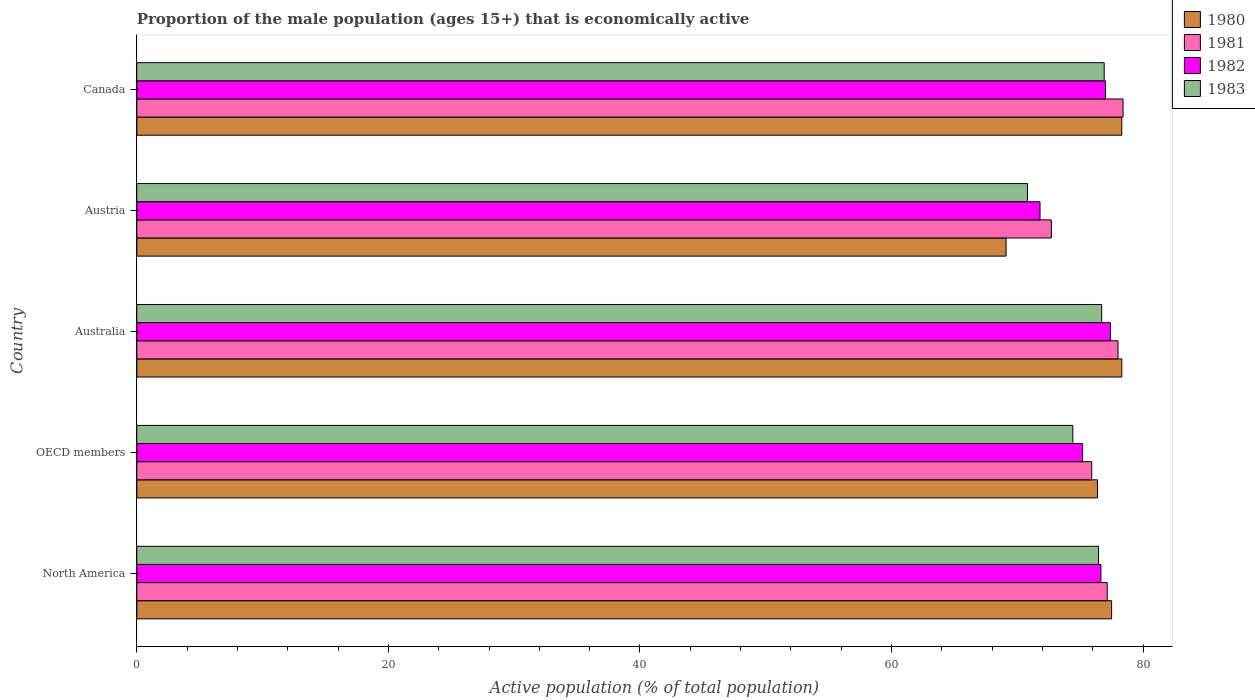Are the number of bars per tick equal to the number of legend labels?
Your response must be concise. Yes. How many bars are there on the 1st tick from the top?
Make the answer very short. 4. How many bars are there on the 4th tick from the bottom?
Ensure brevity in your answer.  4. In how many cases, is the number of bars for a given country not equal to the number of legend labels?
Give a very brief answer. 0. What is the proportion of the male population that is economically active in 1983 in North America?
Keep it short and to the point. 76.45. Across all countries, what is the maximum proportion of the male population that is economically active in 1983?
Provide a succinct answer. 76.9. Across all countries, what is the minimum proportion of the male population that is economically active in 1981?
Your answer should be compact. 72.7. In which country was the proportion of the male population that is economically active in 1980 maximum?
Provide a short and direct response. Australia. What is the total proportion of the male population that is economically active in 1982 in the graph?
Keep it short and to the point. 378.02. What is the difference between the proportion of the male population that is economically active in 1980 in Australia and that in OECD members?
Your response must be concise. 1.93. What is the difference between the proportion of the male population that is economically active in 1980 in Austria and the proportion of the male population that is economically active in 1983 in Canada?
Provide a succinct answer. -7.8. What is the average proportion of the male population that is economically active in 1982 per country?
Offer a terse response. 75.6. What is the difference between the proportion of the male population that is economically active in 1983 and proportion of the male population that is economically active in 1981 in Australia?
Make the answer very short. -1.3. In how many countries, is the proportion of the male population that is economically active in 1982 greater than 52 %?
Make the answer very short. 5. What is the ratio of the proportion of the male population that is economically active in 1982 in Austria to that in Canada?
Your answer should be compact. 0.93. What is the difference between the highest and the second highest proportion of the male population that is economically active in 1982?
Offer a terse response. 0.4. What is the difference between the highest and the lowest proportion of the male population that is economically active in 1980?
Your answer should be very brief. 9.2. In how many countries, is the proportion of the male population that is economically active in 1983 greater than the average proportion of the male population that is economically active in 1983 taken over all countries?
Offer a terse response. 3. Is the sum of the proportion of the male population that is economically active in 1980 in Australia and North America greater than the maximum proportion of the male population that is economically active in 1983 across all countries?
Make the answer very short. Yes. What does the 3rd bar from the top in Australia represents?
Offer a terse response. 1981. What does the 3rd bar from the bottom in Austria represents?
Offer a very short reply. 1982. How many countries are there in the graph?
Give a very brief answer. 5. Does the graph contain any zero values?
Your response must be concise. No. Where does the legend appear in the graph?
Offer a very short reply. Top right. How many legend labels are there?
Your answer should be very brief. 4. How are the legend labels stacked?
Give a very brief answer. Vertical. What is the title of the graph?
Your response must be concise. Proportion of the male population (ages 15+) that is economically active. Does "1977" appear as one of the legend labels in the graph?
Offer a very short reply. No. What is the label or title of the X-axis?
Ensure brevity in your answer.  Active population (% of total population). What is the Active population (% of total population) of 1980 in North America?
Your response must be concise. 77.49. What is the Active population (% of total population) in 1981 in North America?
Give a very brief answer. 77.14. What is the Active population (% of total population) in 1982 in North America?
Offer a very short reply. 76.64. What is the Active population (% of total population) of 1983 in North America?
Give a very brief answer. 76.45. What is the Active population (% of total population) of 1980 in OECD members?
Offer a terse response. 76.37. What is the Active population (% of total population) in 1981 in OECD members?
Make the answer very short. 75.91. What is the Active population (% of total population) in 1982 in OECD members?
Offer a very short reply. 75.18. What is the Active population (% of total population) of 1983 in OECD members?
Ensure brevity in your answer.  74.41. What is the Active population (% of total population) of 1980 in Australia?
Ensure brevity in your answer.  78.3. What is the Active population (% of total population) in 1981 in Australia?
Offer a very short reply. 78. What is the Active population (% of total population) in 1982 in Australia?
Make the answer very short. 77.4. What is the Active population (% of total population) of 1983 in Australia?
Offer a very short reply. 76.7. What is the Active population (% of total population) of 1980 in Austria?
Your answer should be very brief. 69.1. What is the Active population (% of total population) in 1981 in Austria?
Your answer should be very brief. 72.7. What is the Active population (% of total population) of 1982 in Austria?
Your answer should be compact. 71.8. What is the Active population (% of total population) of 1983 in Austria?
Offer a terse response. 70.8. What is the Active population (% of total population) of 1980 in Canada?
Give a very brief answer. 78.3. What is the Active population (% of total population) in 1981 in Canada?
Offer a terse response. 78.4. What is the Active population (% of total population) in 1982 in Canada?
Provide a short and direct response. 77. What is the Active population (% of total population) in 1983 in Canada?
Your answer should be compact. 76.9. Across all countries, what is the maximum Active population (% of total population) of 1980?
Keep it short and to the point. 78.3. Across all countries, what is the maximum Active population (% of total population) in 1981?
Give a very brief answer. 78.4. Across all countries, what is the maximum Active population (% of total population) in 1982?
Provide a short and direct response. 77.4. Across all countries, what is the maximum Active population (% of total population) of 1983?
Keep it short and to the point. 76.9. Across all countries, what is the minimum Active population (% of total population) of 1980?
Your response must be concise. 69.1. Across all countries, what is the minimum Active population (% of total population) of 1981?
Ensure brevity in your answer.  72.7. Across all countries, what is the minimum Active population (% of total population) in 1982?
Provide a short and direct response. 71.8. Across all countries, what is the minimum Active population (% of total population) of 1983?
Offer a terse response. 70.8. What is the total Active population (% of total population) of 1980 in the graph?
Ensure brevity in your answer.  379.56. What is the total Active population (% of total population) in 1981 in the graph?
Your answer should be very brief. 382.15. What is the total Active population (% of total population) in 1982 in the graph?
Your answer should be very brief. 378.02. What is the total Active population (% of total population) of 1983 in the graph?
Keep it short and to the point. 375.26. What is the difference between the Active population (% of total population) in 1980 in North America and that in OECD members?
Ensure brevity in your answer.  1.12. What is the difference between the Active population (% of total population) of 1981 in North America and that in OECD members?
Provide a succinct answer. 1.23. What is the difference between the Active population (% of total population) of 1982 in North America and that in OECD members?
Ensure brevity in your answer.  1.46. What is the difference between the Active population (% of total population) in 1983 in North America and that in OECD members?
Keep it short and to the point. 2.04. What is the difference between the Active population (% of total population) of 1980 in North America and that in Australia?
Offer a very short reply. -0.81. What is the difference between the Active population (% of total population) of 1981 in North America and that in Australia?
Keep it short and to the point. -0.86. What is the difference between the Active population (% of total population) in 1982 in North America and that in Australia?
Give a very brief answer. -0.76. What is the difference between the Active population (% of total population) in 1983 in North America and that in Australia?
Provide a succinct answer. -0.25. What is the difference between the Active population (% of total population) of 1980 in North America and that in Austria?
Keep it short and to the point. 8.39. What is the difference between the Active population (% of total population) of 1981 in North America and that in Austria?
Your answer should be compact. 4.44. What is the difference between the Active population (% of total population) of 1982 in North America and that in Austria?
Keep it short and to the point. 4.84. What is the difference between the Active population (% of total population) of 1983 in North America and that in Austria?
Provide a succinct answer. 5.65. What is the difference between the Active population (% of total population) of 1980 in North America and that in Canada?
Keep it short and to the point. -0.81. What is the difference between the Active population (% of total population) of 1981 in North America and that in Canada?
Your response must be concise. -1.26. What is the difference between the Active population (% of total population) in 1982 in North America and that in Canada?
Your answer should be very brief. -0.36. What is the difference between the Active population (% of total population) in 1983 in North America and that in Canada?
Ensure brevity in your answer.  -0.45. What is the difference between the Active population (% of total population) of 1980 in OECD members and that in Australia?
Provide a short and direct response. -1.93. What is the difference between the Active population (% of total population) of 1981 in OECD members and that in Australia?
Keep it short and to the point. -2.09. What is the difference between the Active population (% of total population) of 1982 in OECD members and that in Australia?
Make the answer very short. -2.22. What is the difference between the Active population (% of total population) in 1983 in OECD members and that in Australia?
Offer a very short reply. -2.29. What is the difference between the Active population (% of total population) in 1980 in OECD members and that in Austria?
Give a very brief answer. 7.27. What is the difference between the Active population (% of total population) in 1981 in OECD members and that in Austria?
Offer a terse response. 3.21. What is the difference between the Active population (% of total population) of 1982 in OECD members and that in Austria?
Your answer should be very brief. 3.38. What is the difference between the Active population (% of total population) in 1983 in OECD members and that in Austria?
Your response must be concise. 3.61. What is the difference between the Active population (% of total population) in 1980 in OECD members and that in Canada?
Your response must be concise. -1.93. What is the difference between the Active population (% of total population) in 1981 in OECD members and that in Canada?
Provide a succinct answer. -2.49. What is the difference between the Active population (% of total population) of 1982 in OECD members and that in Canada?
Your response must be concise. -1.82. What is the difference between the Active population (% of total population) in 1983 in OECD members and that in Canada?
Your answer should be very brief. -2.49. What is the difference between the Active population (% of total population) of 1980 in Australia and that in Canada?
Give a very brief answer. 0. What is the difference between the Active population (% of total population) of 1980 in Austria and that in Canada?
Your answer should be compact. -9.2. What is the difference between the Active population (% of total population) in 1980 in North America and the Active population (% of total population) in 1981 in OECD members?
Your answer should be very brief. 1.58. What is the difference between the Active population (% of total population) in 1980 in North America and the Active population (% of total population) in 1982 in OECD members?
Your response must be concise. 2.31. What is the difference between the Active population (% of total population) in 1980 in North America and the Active population (% of total population) in 1983 in OECD members?
Offer a very short reply. 3.08. What is the difference between the Active population (% of total population) of 1981 in North America and the Active population (% of total population) of 1982 in OECD members?
Give a very brief answer. 1.96. What is the difference between the Active population (% of total population) of 1981 in North America and the Active population (% of total population) of 1983 in OECD members?
Your answer should be very brief. 2.73. What is the difference between the Active population (% of total population) in 1982 in North America and the Active population (% of total population) in 1983 in OECD members?
Make the answer very short. 2.23. What is the difference between the Active population (% of total population) of 1980 in North America and the Active population (% of total population) of 1981 in Australia?
Provide a short and direct response. -0.51. What is the difference between the Active population (% of total population) of 1980 in North America and the Active population (% of total population) of 1982 in Australia?
Your answer should be compact. 0.09. What is the difference between the Active population (% of total population) in 1980 in North America and the Active population (% of total population) in 1983 in Australia?
Provide a short and direct response. 0.79. What is the difference between the Active population (% of total population) of 1981 in North America and the Active population (% of total population) of 1982 in Australia?
Ensure brevity in your answer.  -0.26. What is the difference between the Active population (% of total population) in 1981 in North America and the Active population (% of total population) in 1983 in Australia?
Provide a succinct answer. 0.44. What is the difference between the Active population (% of total population) of 1982 in North America and the Active population (% of total population) of 1983 in Australia?
Provide a short and direct response. -0.06. What is the difference between the Active population (% of total population) in 1980 in North America and the Active population (% of total population) in 1981 in Austria?
Ensure brevity in your answer.  4.79. What is the difference between the Active population (% of total population) in 1980 in North America and the Active population (% of total population) in 1982 in Austria?
Your answer should be very brief. 5.69. What is the difference between the Active population (% of total population) of 1980 in North America and the Active population (% of total population) of 1983 in Austria?
Offer a terse response. 6.69. What is the difference between the Active population (% of total population) of 1981 in North America and the Active population (% of total population) of 1982 in Austria?
Offer a terse response. 5.34. What is the difference between the Active population (% of total population) in 1981 in North America and the Active population (% of total population) in 1983 in Austria?
Keep it short and to the point. 6.34. What is the difference between the Active population (% of total population) of 1982 in North America and the Active population (% of total population) of 1983 in Austria?
Make the answer very short. 5.84. What is the difference between the Active population (% of total population) of 1980 in North America and the Active population (% of total population) of 1981 in Canada?
Offer a very short reply. -0.91. What is the difference between the Active population (% of total population) of 1980 in North America and the Active population (% of total population) of 1982 in Canada?
Provide a succinct answer. 0.49. What is the difference between the Active population (% of total population) of 1980 in North America and the Active population (% of total population) of 1983 in Canada?
Your answer should be compact. 0.59. What is the difference between the Active population (% of total population) in 1981 in North America and the Active population (% of total population) in 1982 in Canada?
Provide a short and direct response. 0.14. What is the difference between the Active population (% of total population) in 1981 in North America and the Active population (% of total population) in 1983 in Canada?
Offer a very short reply. 0.24. What is the difference between the Active population (% of total population) in 1982 in North America and the Active population (% of total population) in 1983 in Canada?
Your answer should be very brief. -0.26. What is the difference between the Active population (% of total population) in 1980 in OECD members and the Active population (% of total population) in 1981 in Australia?
Ensure brevity in your answer.  -1.63. What is the difference between the Active population (% of total population) of 1980 in OECD members and the Active population (% of total population) of 1982 in Australia?
Your answer should be very brief. -1.03. What is the difference between the Active population (% of total population) of 1980 in OECD members and the Active population (% of total population) of 1983 in Australia?
Give a very brief answer. -0.33. What is the difference between the Active population (% of total population) of 1981 in OECD members and the Active population (% of total population) of 1982 in Australia?
Provide a succinct answer. -1.49. What is the difference between the Active population (% of total population) in 1981 in OECD members and the Active population (% of total population) in 1983 in Australia?
Offer a terse response. -0.79. What is the difference between the Active population (% of total population) of 1982 in OECD members and the Active population (% of total population) of 1983 in Australia?
Offer a terse response. -1.52. What is the difference between the Active population (% of total population) in 1980 in OECD members and the Active population (% of total population) in 1981 in Austria?
Offer a terse response. 3.67. What is the difference between the Active population (% of total population) of 1980 in OECD members and the Active population (% of total population) of 1982 in Austria?
Give a very brief answer. 4.57. What is the difference between the Active population (% of total population) in 1980 in OECD members and the Active population (% of total population) in 1983 in Austria?
Provide a succinct answer. 5.57. What is the difference between the Active population (% of total population) in 1981 in OECD members and the Active population (% of total population) in 1982 in Austria?
Provide a succinct answer. 4.11. What is the difference between the Active population (% of total population) of 1981 in OECD members and the Active population (% of total population) of 1983 in Austria?
Your answer should be very brief. 5.11. What is the difference between the Active population (% of total population) in 1982 in OECD members and the Active population (% of total population) in 1983 in Austria?
Offer a terse response. 4.38. What is the difference between the Active population (% of total population) in 1980 in OECD members and the Active population (% of total population) in 1981 in Canada?
Ensure brevity in your answer.  -2.03. What is the difference between the Active population (% of total population) of 1980 in OECD members and the Active population (% of total population) of 1982 in Canada?
Your answer should be very brief. -0.63. What is the difference between the Active population (% of total population) in 1980 in OECD members and the Active population (% of total population) in 1983 in Canada?
Ensure brevity in your answer.  -0.53. What is the difference between the Active population (% of total population) in 1981 in OECD members and the Active population (% of total population) in 1982 in Canada?
Your response must be concise. -1.09. What is the difference between the Active population (% of total population) in 1981 in OECD members and the Active population (% of total population) in 1983 in Canada?
Keep it short and to the point. -0.99. What is the difference between the Active population (% of total population) in 1982 in OECD members and the Active population (% of total population) in 1983 in Canada?
Your response must be concise. -1.72. What is the difference between the Active population (% of total population) in 1980 in Australia and the Active population (% of total population) in 1981 in Austria?
Provide a short and direct response. 5.6. What is the difference between the Active population (% of total population) in 1980 in Australia and the Active population (% of total population) in 1983 in Austria?
Give a very brief answer. 7.5. What is the difference between the Active population (% of total population) in 1981 in Australia and the Active population (% of total population) in 1982 in Austria?
Provide a succinct answer. 6.2. What is the difference between the Active population (% of total population) of 1980 in Australia and the Active population (% of total population) of 1981 in Canada?
Provide a succinct answer. -0.1. What is the difference between the Active population (% of total population) in 1980 in Australia and the Active population (% of total population) in 1983 in Canada?
Offer a very short reply. 1.4. What is the difference between the Active population (% of total population) of 1982 in Australia and the Active population (% of total population) of 1983 in Canada?
Your response must be concise. 0.5. What is the difference between the Active population (% of total population) of 1980 in Austria and the Active population (% of total population) of 1981 in Canada?
Offer a very short reply. -9.3. What is the difference between the Active population (% of total population) of 1980 in Austria and the Active population (% of total population) of 1982 in Canada?
Offer a very short reply. -7.9. What is the difference between the Active population (% of total population) in 1980 in Austria and the Active population (% of total population) in 1983 in Canada?
Keep it short and to the point. -7.8. What is the difference between the Active population (% of total population) of 1981 in Austria and the Active population (% of total population) of 1982 in Canada?
Make the answer very short. -4.3. What is the difference between the Active population (% of total population) in 1981 in Austria and the Active population (% of total population) in 1983 in Canada?
Give a very brief answer. -4.2. What is the difference between the Active population (% of total population) of 1982 in Austria and the Active population (% of total population) of 1983 in Canada?
Keep it short and to the point. -5.1. What is the average Active population (% of total population) in 1980 per country?
Make the answer very short. 75.91. What is the average Active population (% of total population) in 1981 per country?
Ensure brevity in your answer.  76.43. What is the average Active population (% of total population) in 1982 per country?
Your response must be concise. 75.6. What is the average Active population (% of total population) in 1983 per country?
Make the answer very short. 75.05. What is the difference between the Active population (% of total population) of 1980 and Active population (% of total population) of 1981 in North America?
Your answer should be compact. 0.35. What is the difference between the Active population (% of total population) of 1980 and Active population (% of total population) of 1982 in North America?
Your answer should be compact. 0.85. What is the difference between the Active population (% of total population) of 1980 and Active population (% of total population) of 1983 in North America?
Your response must be concise. 1.04. What is the difference between the Active population (% of total population) in 1981 and Active population (% of total population) in 1982 in North America?
Give a very brief answer. 0.5. What is the difference between the Active population (% of total population) in 1981 and Active population (% of total population) in 1983 in North America?
Keep it short and to the point. 0.69. What is the difference between the Active population (% of total population) in 1982 and Active population (% of total population) in 1983 in North America?
Make the answer very short. 0.19. What is the difference between the Active population (% of total population) of 1980 and Active population (% of total population) of 1981 in OECD members?
Offer a terse response. 0.46. What is the difference between the Active population (% of total population) in 1980 and Active population (% of total population) in 1982 in OECD members?
Offer a very short reply. 1.19. What is the difference between the Active population (% of total population) in 1980 and Active population (% of total population) in 1983 in OECD members?
Keep it short and to the point. 1.96. What is the difference between the Active population (% of total population) in 1981 and Active population (% of total population) in 1982 in OECD members?
Your answer should be compact. 0.73. What is the difference between the Active population (% of total population) in 1981 and Active population (% of total population) in 1983 in OECD members?
Provide a short and direct response. 1.5. What is the difference between the Active population (% of total population) in 1982 and Active population (% of total population) in 1983 in OECD members?
Your response must be concise. 0.77. What is the difference between the Active population (% of total population) of 1980 and Active population (% of total population) of 1983 in Australia?
Your answer should be very brief. 1.6. What is the difference between the Active population (% of total population) in 1981 and Active population (% of total population) in 1982 in Australia?
Your answer should be very brief. 0.6. What is the difference between the Active population (% of total population) of 1981 and Active population (% of total population) of 1983 in Australia?
Offer a terse response. 1.3. What is the difference between the Active population (% of total population) in 1982 and Active population (% of total population) in 1983 in Australia?
Ensure brevity in your answer.  0.7. What is the difference between the Active population (% of total population) in 1980 and Active population (% of total population) in 1982 in Austria?
Provide a succinct answer. -2.7. What is the difference between the Active population (% of total population) in 1981 and Active population (% of total population) in 1982 in Austria?
Provide a succinct answer. 0.9. What is the difference between the Active population (% of total population) of 1980 and Active population (% of total population) of 1981 in Canada?
Make the answer very short. -0.1. What is the difference between the Active population (% of total population) of 1980 and Active population (% of total population) of 1982 in Canada?
Provide a short and direct response. 1.3. What is the difference between the Active population (% of total population) in 1981 and Active population (% of total population) in 1982 in Canada?
Provide a succinct answer. 1.4. What is the ratio of the Active population (% of total population) in 1980 in North America to that in OECD members?
Give a very brief answer. 1.01. What is the ratio of the Active population (% of total population) in 1981 in North America to that in OECD members?
Your response must be concise. 1.02. What is the ratio of the Active population (% of total population) in 1982 in North America to that in OECD members?
Offer a terse response. 1.02. What is the ratio of the Active population (% of total population) in 1983 in North America to that in OECD members?
Offer a terse response. 1.03. What is the ratio of the Active population (% of total population) in 1980 in North America to that in Australia?
Your answer should be compact. 0.99. What is the ratio of the Active population (% of total population) in 1982 in North America to that in Australia?
Your answer should be very brief. 0.99. What is the ratio of the Active population (% of total population) in 1980 in North America to that in Austria?
Your answer should be compact. 1.12. What is the ratio of the Active population (% of total population) of 1981 in North America to that in Austria?
Your answer should be very brief. 1.06. What is the ratio of the Active population (% of total population) in 1982 in North America to that in Austria?
Your response must be concise. 1.07. What is the ratio of the Active population (% of total population) of 1983 in North America to that in Austria?
Keep it short and to the point. 1.08. What is the ratio of the Active population (% of total population) in 1980 in North America to that in Canada?
Make the answer very short. 0.99. What is the ratio of the Active population (% of total population) in 1981 in North America to that in Canada?
Your response must be concise. 0.98. What is the ratio of the Active population (% of total population) in 1982 in North America to that in Canada?
Your answer should be compact. 1. What is the ratio of the Active population (% of total population) of 1983 in North America to that in Canada?
Offer a terse response. 0.99. What is the ratio of the Active population (% of total population) in 1980 in OECD members to that in Australia?
Give a very brief answer. 0.98. What is the ratio of the Active population (% of total population) in 1981 in OECD members to that in Australia?
Keep it short and to the point. 0.97. What is the ratio of the Active population (% of total population) of 1982 in OECD members to that in Australia?
Your response must be concise. 0.97. What is the ratio of the Active population (% of total population) in 1983 in OECD members to that in Australia?
Offer a terse response. 0.97. What is the ratio of the Active population (% of total population) of 1980 in OECD members to that in Austria?
Give a very brief answer. 1.11. What is the ratio of the Active population (% of total population) in 1981 in OECD members to that in Austria?
Offer a very short reply. 1.04. What is the ratio of the Active population (% of total population) in 1982 in OECD members to that in Austria?
Provide a succinct answer. 1.05. What is the ratio of the Active population (% of total population) of 1983 in OECD members to that in Austria?
Provide a short and direct response. 1.05. What is the ratio of the Active population (% of total population) of 1980 in OECD members to that in Canada?
Provide a succinct answer. 0.98. What is the ratio of the Active population (% of total population) of 1981 in OECD members to that in Canada?
Offer a very short reply. 0.97. What is the ratio of the Active population (% of total population) in 1982 in OECD members to that in Canada?
Your answer should be compact. 0.98. What is the ratio of the Active population (% of total population) of 1983 in OECD members to that in Canada?
Provide a succinct answer. 0.97. What is the ratio of the Active population (% of total population) of 1980 in Australia to that in Austria?
Provide a short and direct response. 1.13. What is the ratio of the Active population (% of total population) in 1981 in Australia to that in Austria?
Ensure brevity in your answer.  1.07. What is the ratio of the Active population (% of total population) in 1982 in Australia to that in Austria?
Keep it short and to the point. 1.08. What is the ratio of the Active population (% of total population) of 1983 in Australia to that in Austria?
Provide a succinct answer. 1.08. What is the ratio of the Active population (% of total population) in 1980 in Australia to that in Canada?
Your answer should be compact. 1. What is the ratio of the Active population (% of total population) in 1981 in Australia to that in Canada?
Offer a terse response. 0.99. What is the ratio of the Active population (% of total population) of 1983 in Australia to that in Canada?
Make the answer very short. 1. What is the ratio of the Active population (% of total population) in 1980 in Austria to that in Canada?
Provide a short and direct response. 0.88. What is the ratio of the Active population (% of total population) of 1981 in Austria to that in Canada?
Provide a short and direct response. 0.93. What is the ratio of the Active population (% of total population) in 1982 in Austria to that in Canada?
Keep it short and to the point. 0.93. What is the ratio of the Active population (% of total population) in 1983 in Austria to that in Canada?
Offer a very short reply. 0.92. What is the difference between the highest and the second highest Active population (% of total population) in 1981?
Your answer should be very brief. 0.4. What is the difference between the highest and the second highest Active population (% of total population) in 1982?
Provide a short and direct response. 0.4. What is the difference between the highest and the second highest Active population (% of total population) of 1983?
Your answer should be very brief. 0.2. What is the difference between the highest and the lowest Active population (% of total population) of 1980?
Your response must be concise. 9.2. 